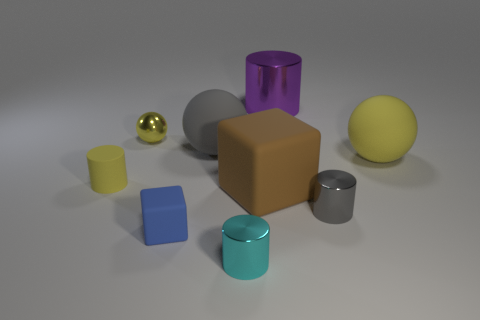How many rubber things are blue cubes or purple cylinders?
Ensure brevity in your answer.  1. There is a sphere that is on the left side of the gray thing that is to the left of the tiny gray thing; how many brown blocks are right of it?
Your answer should be very brief. 1. There is a yellow rubber object that is left of the purple thing; is its size the same as the gray object behind the large yellow rubber sphere?
Offer a terse response. No. What is the material of the yellow thing that is the same shape as the purple object?
Make the answer very short. Rubber. What number of large things are yellow shiny balls or yellow shiny blocks?
Make the answer very short. 0. What material is the purple cylinder?
Offer a terse response. Metal. There is a ball that is both on the right side of the blue matte object and left of the gray metallic thing; what material is it made of?
Ensure brevity in your answer.  Rubber. There is a tiny ball; is its color the same as the sphere that is right of the big metal cylinder?
Provide a succinct answer. Yes. What is the material of the brown block that is the same size as the purple cylinder?
Ensure brevity in your answer.  Rubber. Is there a cylinder made of the same material as the small sphere?
Provide a succinct answer. Yes. 